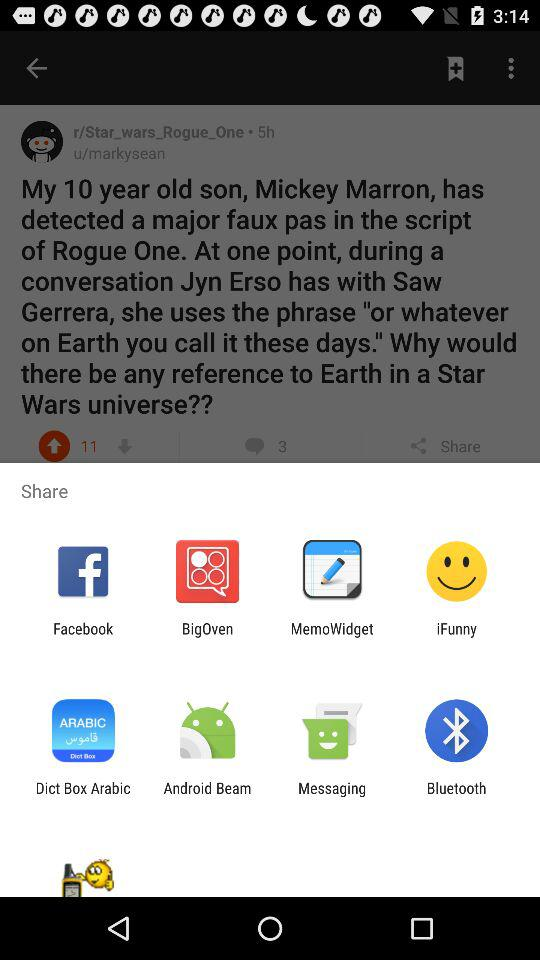When was the post updated? The post was updated 5 hours ago. 